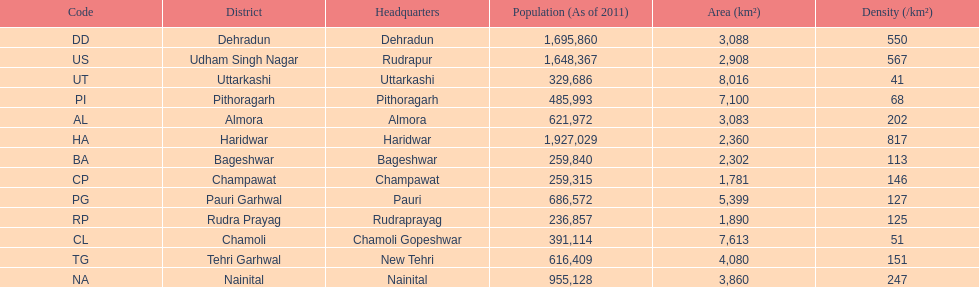What is the last code listed? UT. 